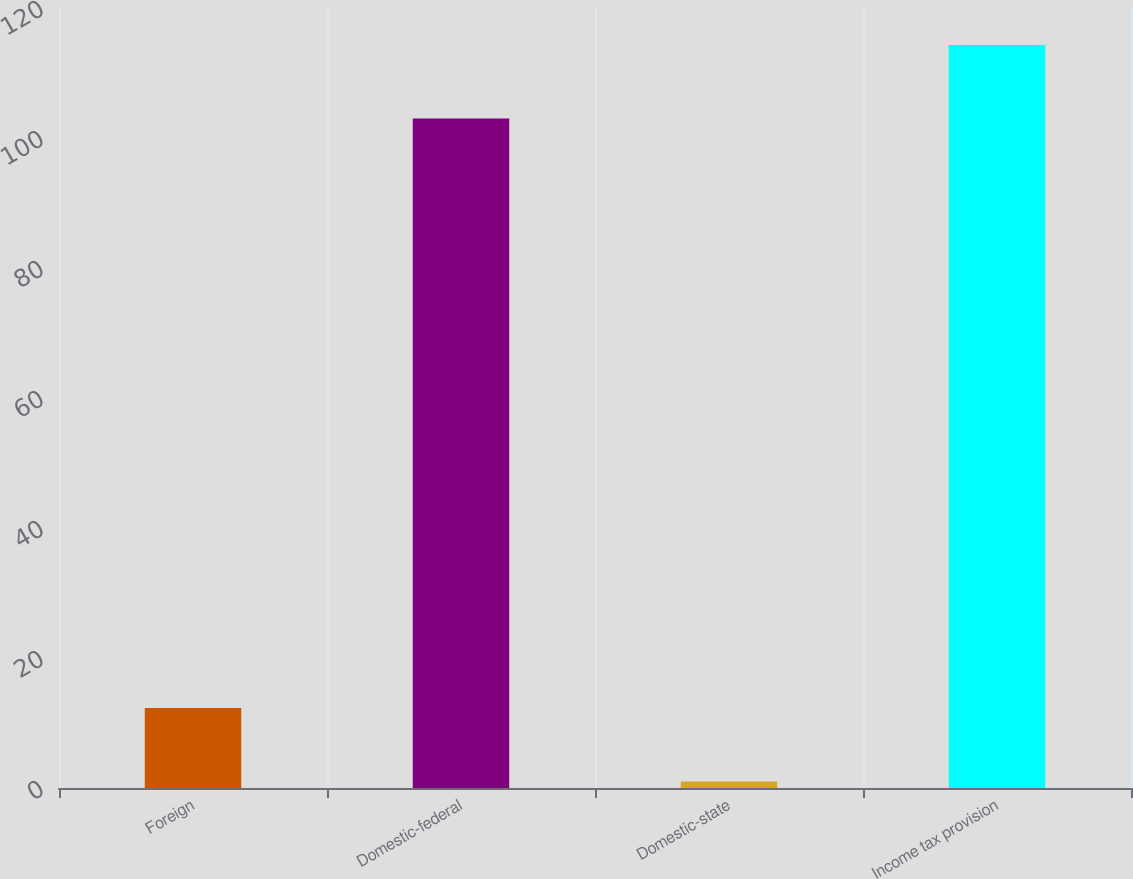<chart> <loc_0><loc_0><loc_500><loc_500><bar_chart><fcel>Foreign<fcel>Domestic-federal<fcel>Domestic-state<fcel>Income tax provision<nl><fcel>12.3<fcel>103<fcel>1<fcel>114.3<nl></chart> 